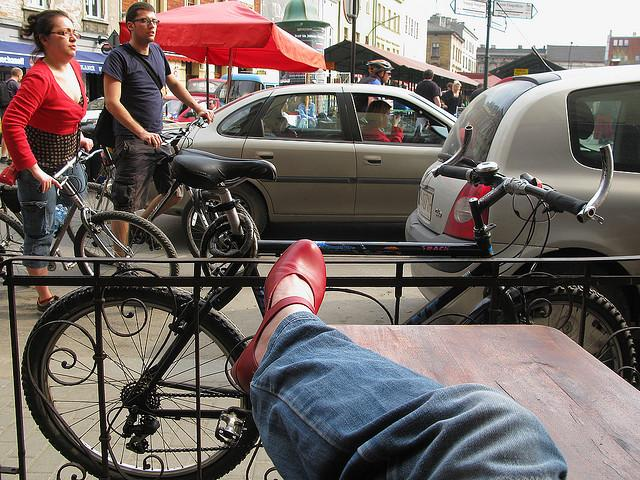How is doing what the photo taker is doing with their leg considered? Please explain your reasoning. slightly rude. A person has their foot and leg resting on a table. 